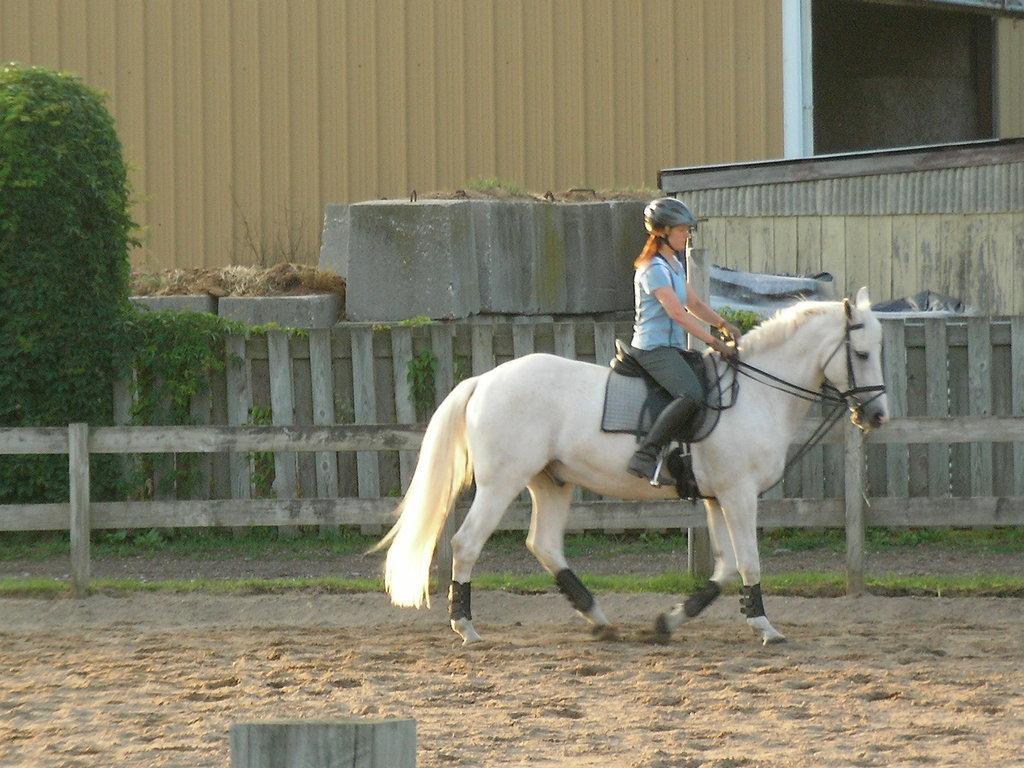Describe this image in one or two sentences. In this image there is a person sitting on the horse. Around her, there is a wooden fence. At the bottom of the image there is sand on the surface. There are bushes, concrete structures. In the background of the image there is a wall. There is a door. 